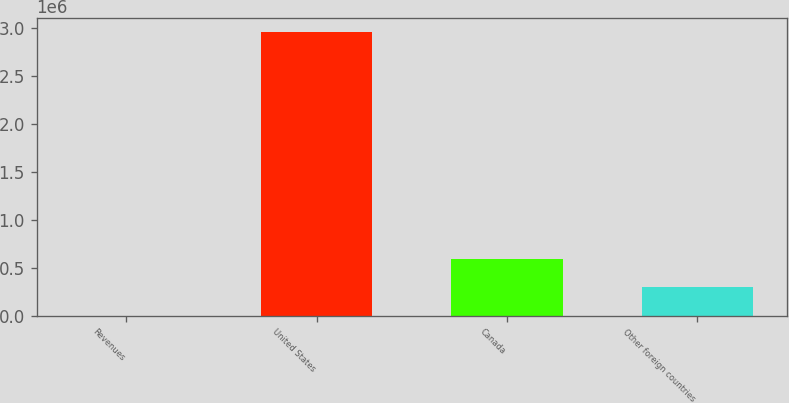Convert chart to OTSL. <chart><loc_0><loc_0><loc_500><loc_500><bar_chart><fcel>Revenues<fcel>United States<fcel>Canada<fcel>Other foreign countries<nl><fcel>2013<fcel>2.95167e+06<fcel>591945<fcel>296979<nl></chart> 